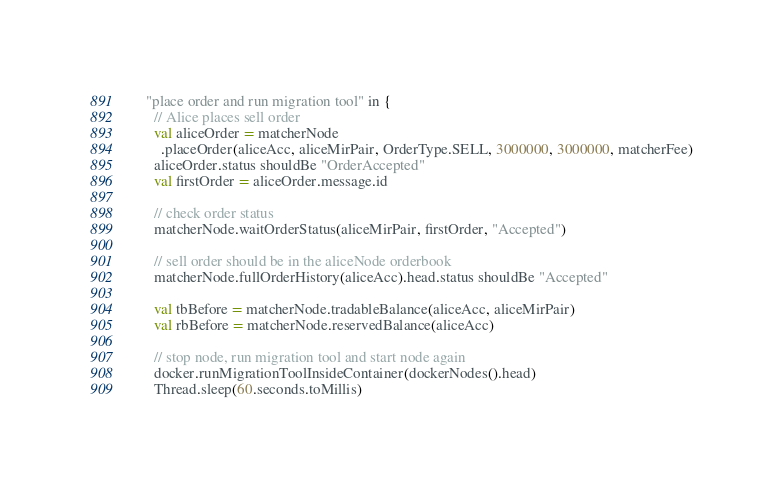Convert code to text. <code><loc_0><loc_0><loc_500><loc_500><_Scala_>    "place order and run migration tool" in {
      // Alice places sell order
      val aliceOrder = matcherNode
        .placeOrder(aliceAcc, aliceMirPair, OrderType.SELL, 3000000, 3000000, matcherFee)
      aliceOrder.status shouldBe "OrderAccepted"
      val firstOrder = aliceOrder.message.id

      // check order status
      matcherNode.waitOrderStatus(aliceMirPair, firstOrder, "Accepted")

      // sell order should be in the aliceNode orderbook
      matcherNode.fullOrderHistory(aliceAcc).head.status shouldBe "Accepted"

      val tbBefore = matcherNode.tradableBalance(aliceAcc, aliceMirPair)
      val rbBefore = matcherNode.reservedBalance(aliceAcc)

      // stop node, run migration tool and start node again
      docker.runMigrationToolInsideContainer(dockerNodes().head)
      Thread.sleep(60.seconds.toMillis)
</code> 